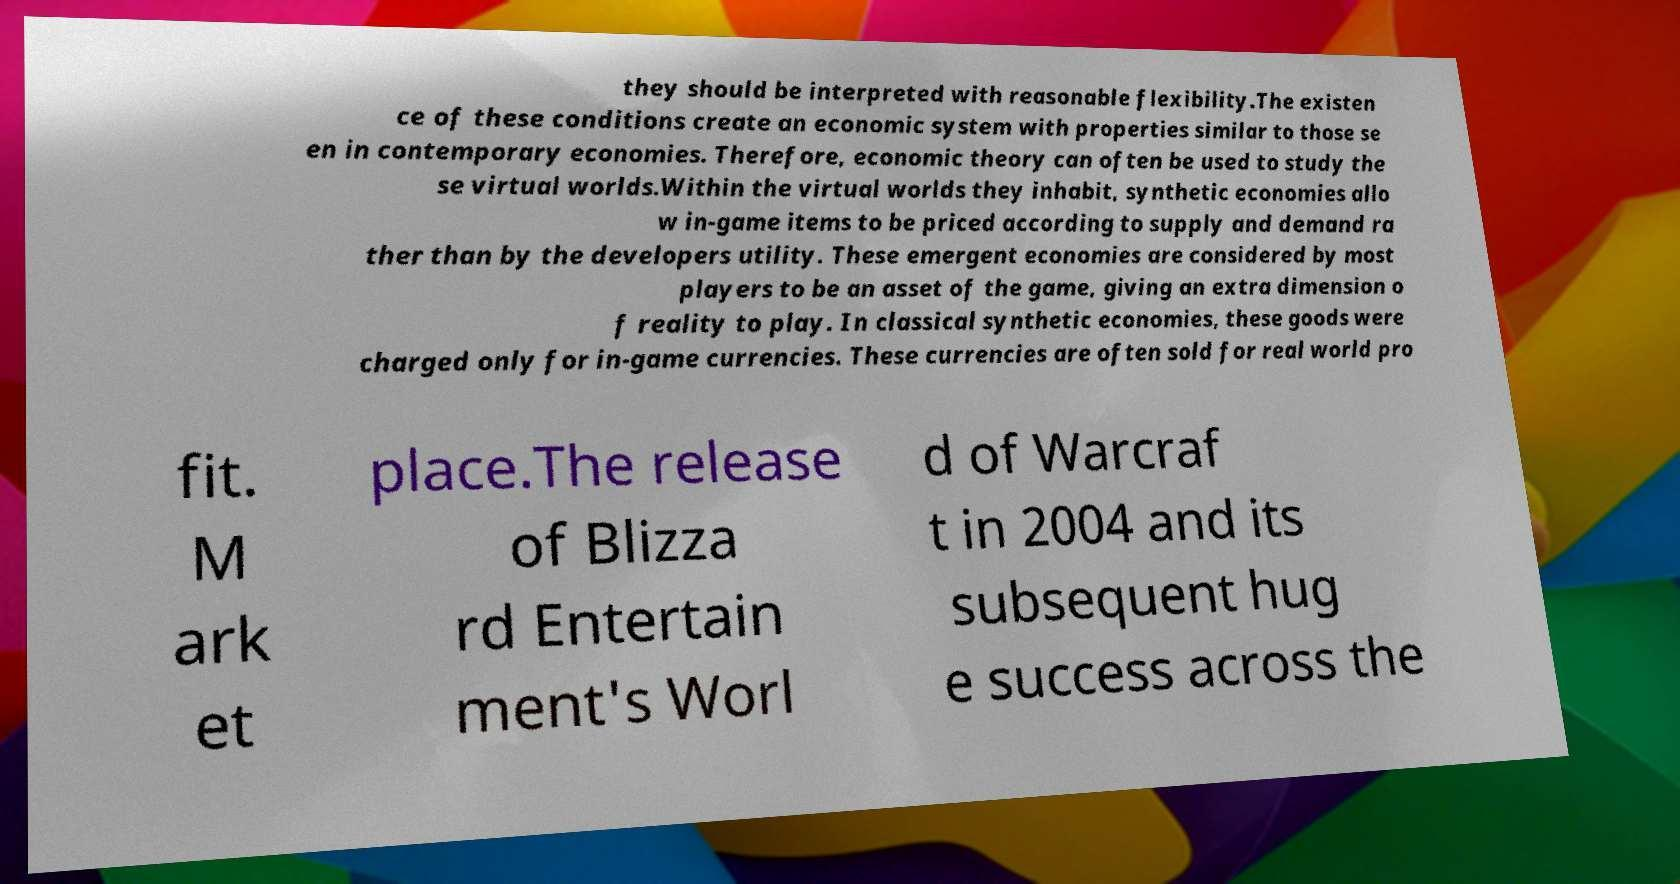Could you assist in decoding the text presented in this image and type it out clearly? they should be interpreted with reasonable flexibility.The existen ce of these conditions create an economic system with properties similar to those se en in contemporary economies. Therefore, economic theory can often be used to study the se virtual worlds.Within the virtual worlds they inhabit, synthetic economies allo w in-game items to be priced according to supply and demand ra ther than by the developers utility. These emergent economies are considered by most players to be an asset of the game, giving an extra dimension o f reality to play. In classical synthetic economies, these goods were charged only for in-game currencies. These currencies are often sold for real world pro fit. M ark et place.The release of Blizza rd Entertain ment's Worl d of Warcraf t in 2004 and its subsequent hug e success across the 